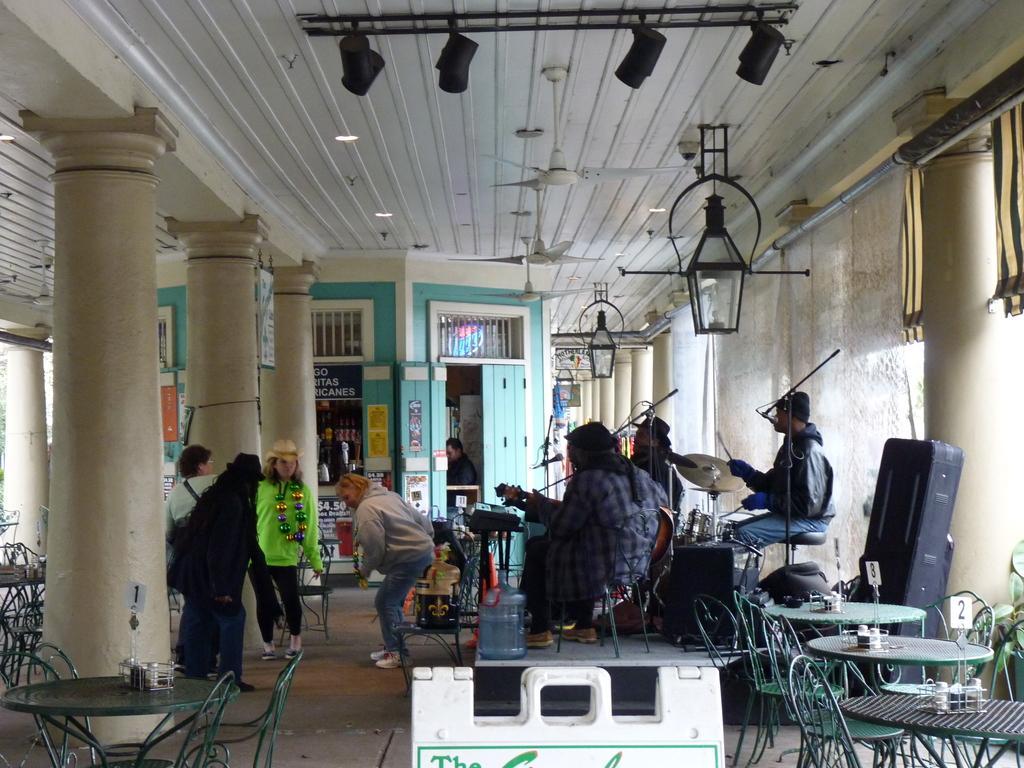How would you summarize this image in a sentence or two? In this image there are few people who are playing the musical instruments, while the other people are standing in front of them. At the background there is door and the store. At the top there is ceiling which has fans and lights to it. To the left side there are pillars,tables and chairs which are at the backside of the people who are standing. 